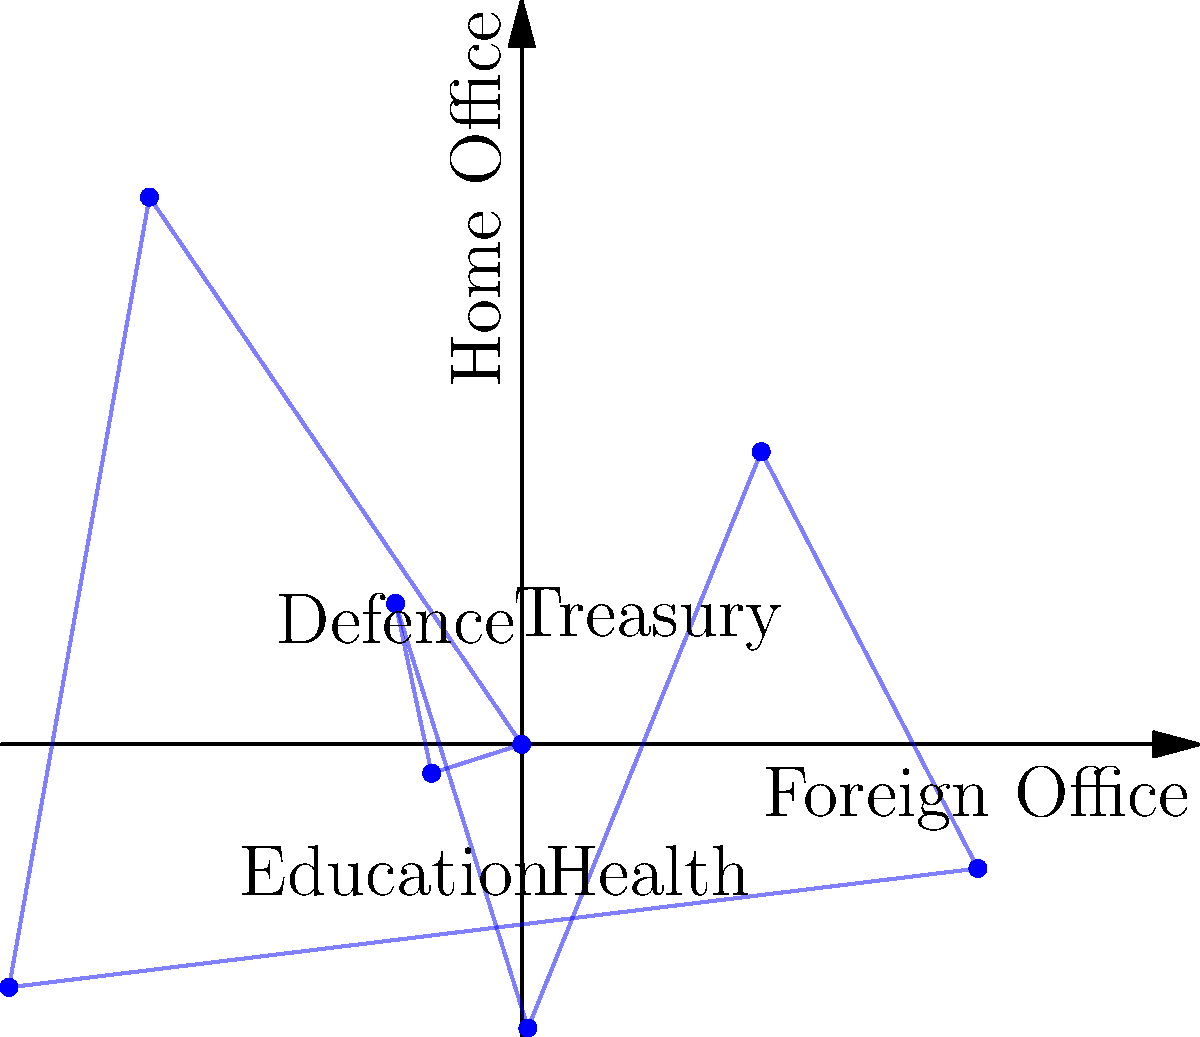In the rose diagram representing gender balance in various civil service departments, which department shows the highest percentage of female employees? To determine which department has the highest percentage of female employees, we need to analyze the rose diagram:

1. The diagram represents eight different civil service departments.
2. The distance from the center to each point on the diagram represents the percentage of female employees in that department.
3. The departments are arranged clockwise, starting from the positive x-axis:
   - Foreign Office (0°)
   - Treasury (45°)
   - Home Office (90°)
   - Defence (135°)
   - Unlabeled department (180°)
   - Education (225°)
   - Health (270°)
   - Unlabeled department (315°)
4. By comparing the distances from the center, we can see that the point at 0° (Foreign Office) extends the furthest from the center.
5. This indicates that the Foreign Office has the highest percentage of female employees among the departments shown.
Answer: Foreign Office 